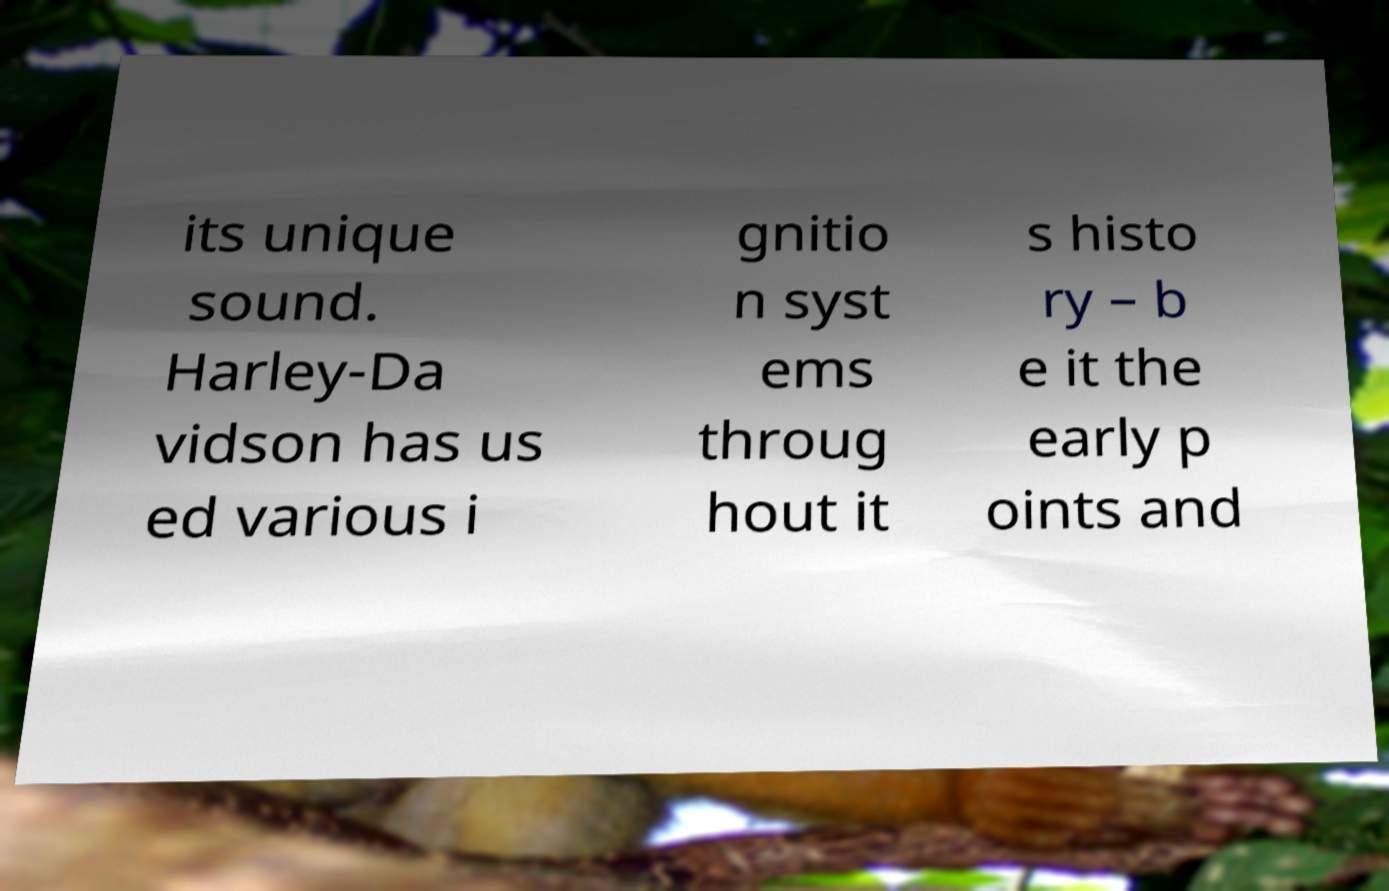For documentation purposes, I need the text within this image transcribed. Could you provide that? its unique sound. Harley-Da vidson has us ed various i gnitio n syst ems throug hout it s histo ry – b e it the early p oints and 